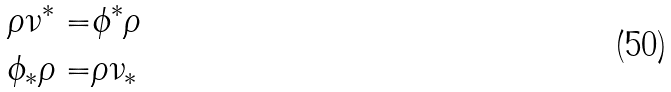<formula> <loc_0><loc_0><loc_500><loc_500>\rho \nu ^ { * } = & \phi ^ { * } \rho \\ \phi _ { * } \rho = & \rho \nu _ { * }</formula> 